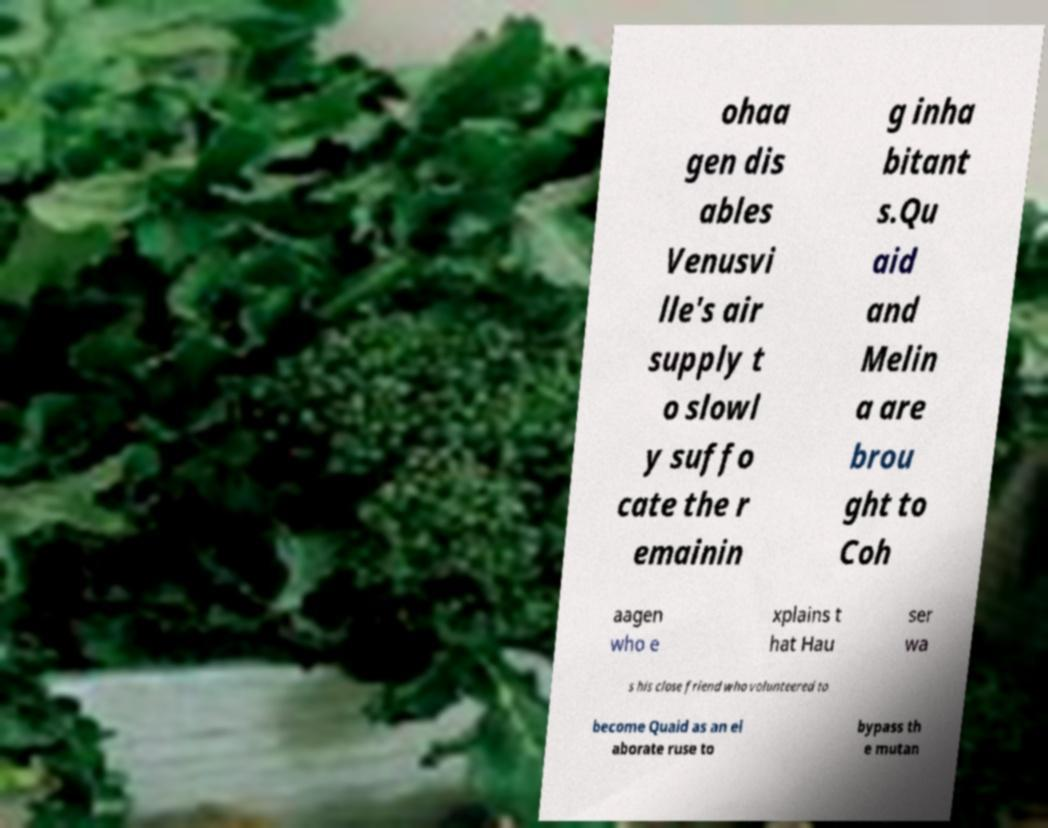Please identify and transcribe the text found in this image. ohaa gen dis ables Venusvi lle's air supply t o slowl y suffo cate the r emainin g inha bitant s.Qu aid and Melin a are brou ght to Coh aagen who e xplains t hat Hau ser wa s his close friend who volunteered to become Quaid as an el aborate ruse to bypass th e mutan 